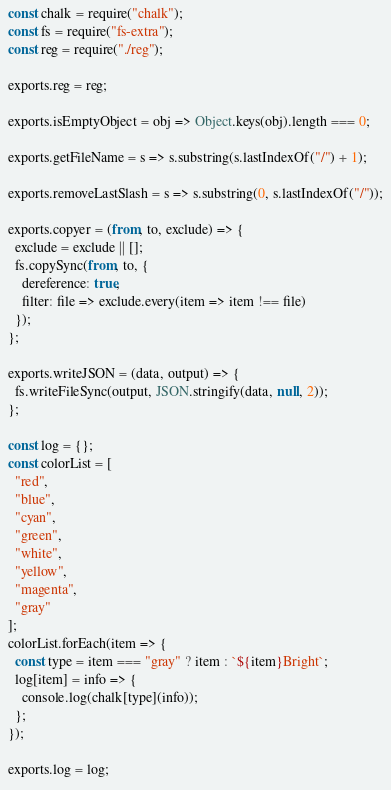Convert code to text. <code><loc_0><loc_0><loc_500><loc_500><_JavaScript_>const chalk = require("chalk");
const fs = require("fs-extra");
const reg = require("./reg");

exports.reg = reg;

exports.isEmptyObject = obj => Object.keys(obj).length === 0;

exports.getFileName = s => s.substring(s.lastIndexOf("/") + 1);

exports.removeLastSlash = s => s.substring(0, s.lastIndexOf("/"));

exports.copyer = (from, to, exclude) => {
  exclude = exclude || [];
  fs.copySync(from, to, {
    dereference: true,
    filter: file => exclude.every(item => item !== file)
  });
};

exports.writeJSON = (data, output) => {
  fs.writeFileSync(output, JSON.stringify(data, null, 2));
};

const log = {};
const colorList = [
  "red",
  "blue",
  "cyan",
  "green",
  "white",
  "yellow",
  "magenta",
  "gray"
];
colorList.forEach(item => {
  const type = item === "gray" ? item : `${item}Bright`;
  log[item] = info => {
    console.log(chalk[type](info));
  };
});

exports.log = log;
</code> 